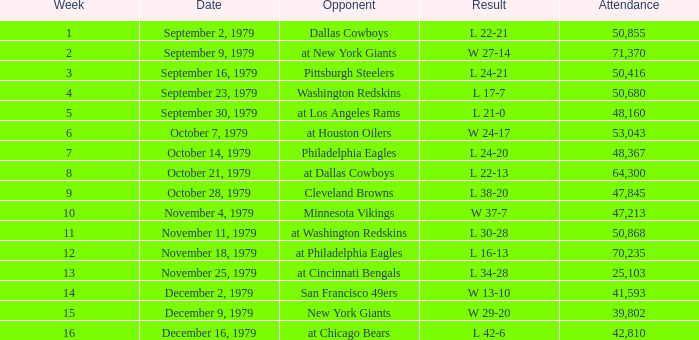Help me parse the entirety of this table. {'header': ['Week', 'Date', 'Opponent', 'Result', 'Attendance'], 'rows': [['1', 'September 2, 1979', 'Dallas Cowboys', 'L 22-21', '50,855'], ['2', 'September 9, 1979', 'at New York Giants', 'W 27-14', '71,370'], ['3', 'September 16, 1979', 'Pittsburgh Steelers', 'L 24-21', '50,416'], ['4', 'September 23, 1979', 'Washington Redskins', 'L 17-7', '50,680'], ['5', 'September 30, 1979', 'at Los Angeles Rams', 'L 21-0', '48,160'], ['6', 'October 7, 1979', 'at Houston Oilers', 'W 24-17', '53,043'], ['7', 'October 14, 1979', 'Philadelphia Eagles', 'L 24-20', '48,367'], ['8', 'October 21, 1979', 'at Dallas Cowboys', 'L 22-13', '64,300'], ['9', 'October 28, 1979', 'Cleveland Browns', 'L 38-20', '47,845'], ['10', 'November 4, 1979', 'Minnesota Vikings', 'W 37-7', '47,213'], ['11', 'November 11, 1979', 'at Washington Redskins', 'L 30-28', '50,868'], ['12', 'November 18, 1979', 'at Philadelphia Eagles', 'L 16-13', '70,235'], ['13', 'November 25, 1979', 'at Cincinnati Bengals', 'L 34-28', '25,103'], ['14', 'December 2, 1979', 'San Francisco 49ers', 'W 13-10', '41,593'], ['15', 'December 9, 1979', 'New York Giants', 'W 29-20', '39,802'], ['16', 'December 16, 1979', 'at Chicago Bears', 'L 42-6', '42,810']]} What is the highest week when attendance is greater than 64,300 with a result of w 27-14? 2.0. 